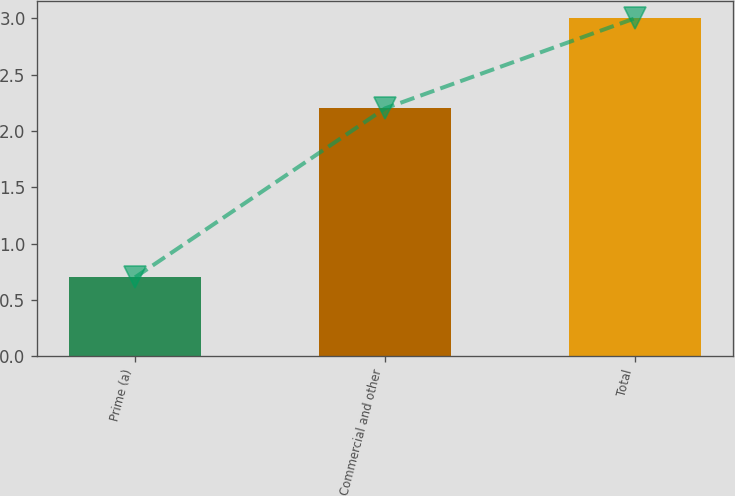Convert chart to OTSL. <chart><loc_0><loc_0><loc_500><loc_500><bar_chart><fcel>Prime (a)<fcel>Commercial and other<fcel>Total<nl><fcel>0.7<fcel>2.2<fcel>3<nl></chart> 